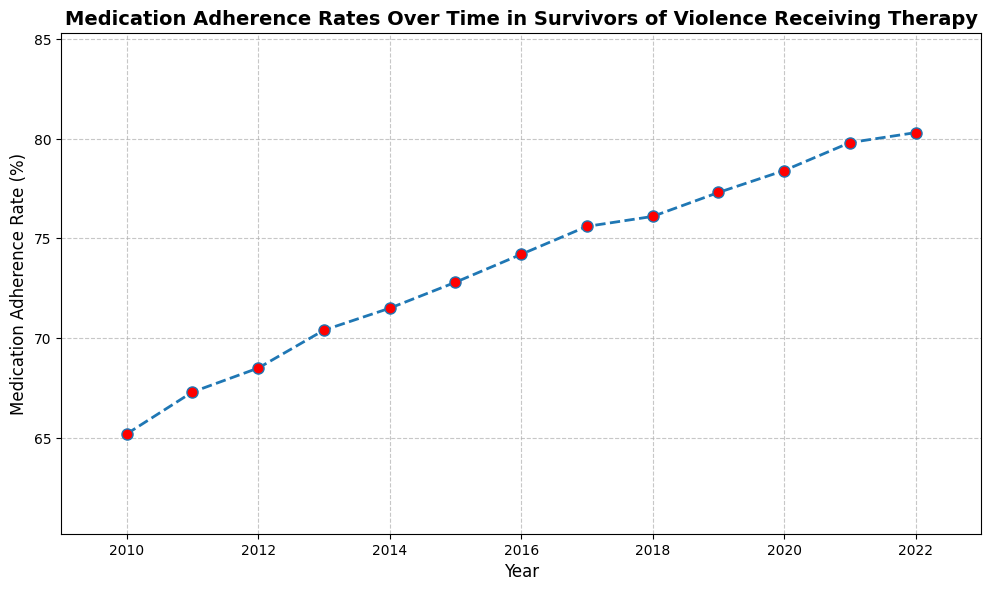How does the medication adherence rate change from 2010 to 2022? To determine the change, subtract the 2010 value (65.2%) from the 2022 value (80.3%). This results in 80.3 - 65.2 = 15.1.
Answer: 15.1 What is the average medication adherence rate between 2010 and 2022? To find the average, sum all the yearly adherence rates (65.2 + 67.3 + 68.5 + 70.4 + 71.5 + 72.8 + 74.2 + 75.6 + 76.1 + 77.3 + 78.4 + 79.8 + 80.3) and divide by the total number of years (13). The sum is 928.4, so the average is 928.4 / 13 = 71.41.
Answer: 71.41 Which year had the highest medication adherence rate? Looking at the plot, 2022 has the highest adherence rate at 80.3%.
Answer: 2022 How does the adherence rate in 2020 compare to that of 2015? To compare, note that 2020's rate is 78.4% and 2015's rate is 72.8%. The difference is 78.4 - 72.8 = 5.6.
Answer: 5.6 Which year saw the biggest increase in medication adherence rate compared to the previous year? Compare the year-to-year differences: (67.3 - 65.2 = 2.1), (68.5 - 67.3 = 1.2), (70.4 - 68.5 = 1.9), (71.5 - 70.4 = 1.1), (72.8 - 71.5 = 1.3), (74.2 - 72.8 = 1.4), (75.6 - 74.2 = 1.4), (76.1 - 75.6 = 0.5), (77.3 - 76.1 = 1.2), (78.4 - 77.3 = 1.1), (79.8 - 78.4 = 1.4), (80.3 - 79.8 = 0.5). The biggest increase, 2.1, occurred between 2010 and 2011.
Answer: 2011 Is the adherence rate in 2016 above or below the overall average from 2010 to 2022? The adherence rate in 2016 is 74.2%. The overall average from 2010 to 2022 is 71.41%. Since 74.2 is greater than 71.41, it is above the average.
Answer: Above What is the visual color of the markers on the plot? The markers on the plot are described as having a red face color.
Answer: Red Calculate the median adherence rate over the given period. To find the median, first list the rates in ascending order: (65.2, 67.3, 68.5, 70.4, 71.5, 72.8, 74.2, 75.6, 76.1, 77.3, 78.4, 79.8, 80.3). The median is the middle value, which for an odd number of 13 values, is the 7th value: 74.2.
Answer: 74.2 What was the adherence rate in the middle year of 2016, and how does it compare to its previous year? The middle year's rate, 2016, is 74.2%. The previous year, 2015, had a rate of 72.8%. So, 74.2 - 72.8 = 1.4 increase.
Answer: 1.4 Describe the general trend of the medication adherence rate over the years. Observing the plot, the medication adherence rate consistently increases over the years, starting from 65.2% in 2010 and gradually rising each year to 80.3% in 2022.
Answer: Increasing 